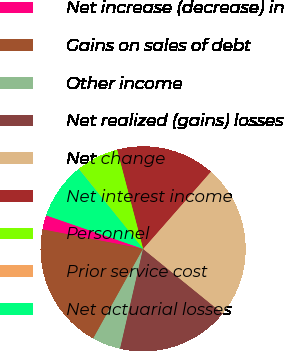<chart> <loc_0><loc_0><loc_500><loc_500><pie_chart><fcel>Net increase (decrease) in<fcel>Gains on sales of debt<fcel>Other income<fcel>Net realized (gains) losses<fcel>Net change<fcel>Net interest income<fcel>Personnel<fcel>Prior service cost<fcel>Net actuarial losses<nl><fcel>2.26%<fcel>19.97%<fcel>4.47%<fcel>17.75%<fcel>24.39%<fcel>15.54%<fcel>6.68%<fcel>0.04%<fcel>8.9%<nl></chart> 